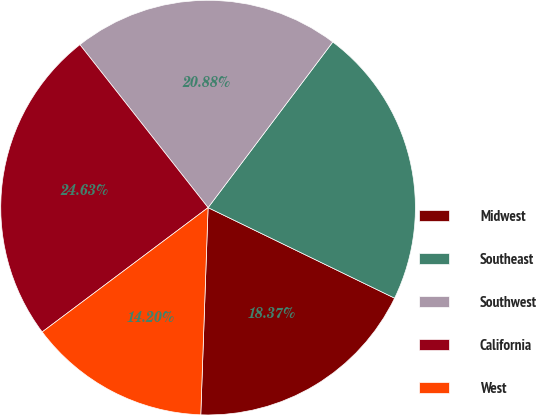<chart> <loc_0><loc_0><loc_500><loc_500><pie_chart><fcel>Midwest<fcel>Southeast<fcel>Southwest<fcel>California<fcel>West<nl><fcel>18.37%<fcel>21.92%<fcel>20.88%<fcel>24.63%<fcel>14.2%<nl></chart> 